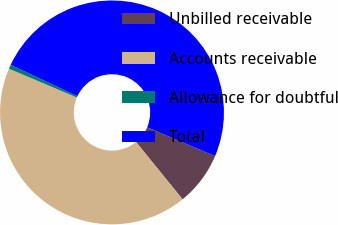Convert chart to OTSL. <chart><loc_0><loc_0><loc_500><loc_500><pie_chart><fcel>Unbilled receivable<fcel>Accounts receivable<fcel>Allowance for doubtful<fcel>Total<nl><fcel>7.76%<fcel>42.24%<fcel>0.6%<fcel>49.4%<nl></chart> 